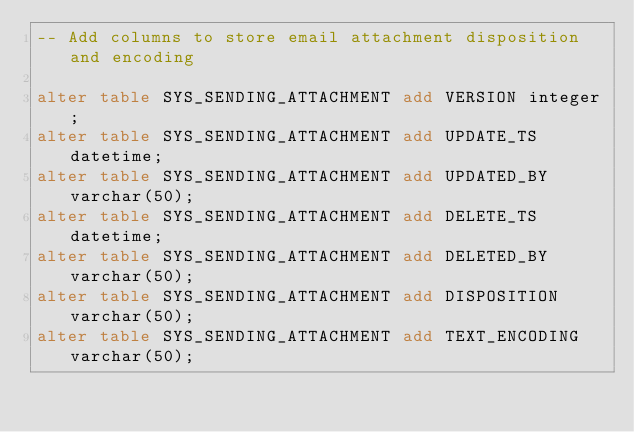Convert code to text. <code><loc_0><loc_0><loc_500><loc_500><_SQL_>-- Add columns to store email attachment disposition and encoding

alter table SYS_SENDING_ATTACHMENT add VERSION integer;
alter table SYS_SENDING_ATTACHMENT add UPDATE_TS datetime;
alter table SYS_SENDING_ATTACHMENT add UPDATED_BY varchar(50);
alter table SYS_SENDING_ATTACHMENT add DELETE_TS datetime;
alter table SYS_SENDING_ATTACHMENT add DELETED_BY varchar(50);
alter table SYS_SENDING_ATTACHMENT add DISPOSITION varchar(50);
alter table SYS_SENDING_ATTACHMENT add TEXT_ENCODING varchar(50);
</code> 